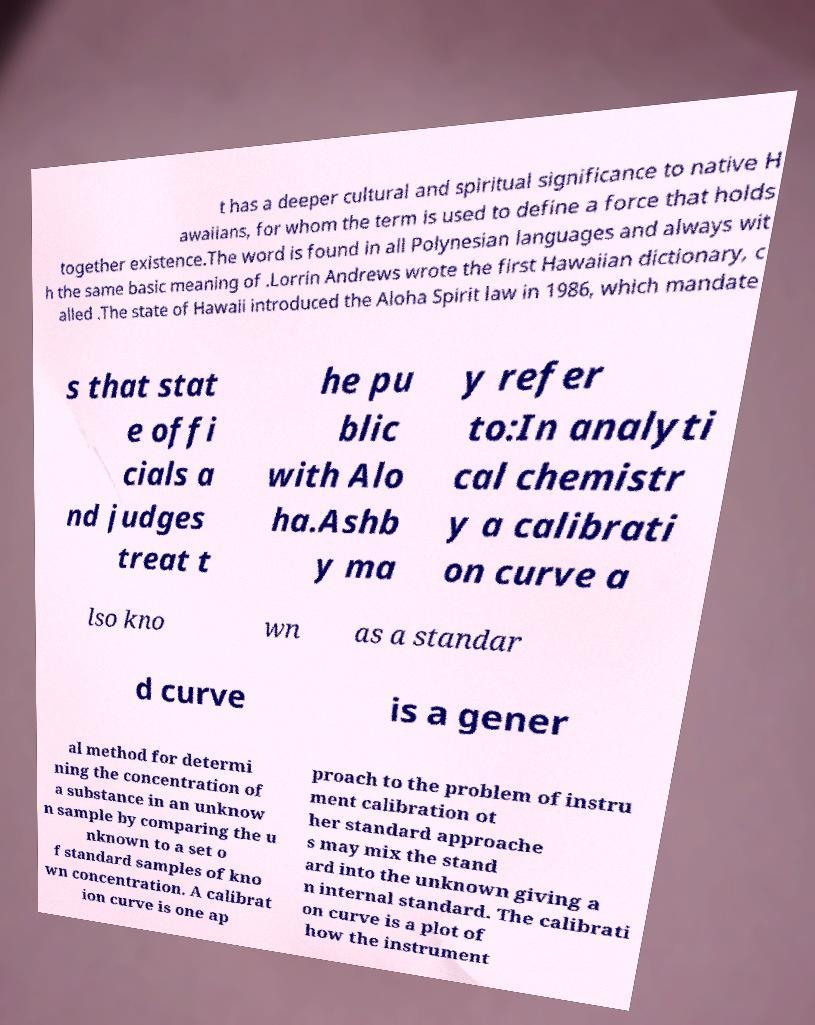Could you assist in decoding the text presented in this image and type it out clearly? t has a deeper cultural and spiritual significance to native H awaiians, for whom the term is used to define a force that holds together existence.The word is found in all Polynesian languages and always wit h the same basic meaning of .Lorrin Andrews wrote the first Hawaiian dictionary, c alled .The state of Hawaii introduced the Aloha Spirit law in 1986, which mandate s that stat e offi cials a nd judges treat t he pu blic with Alo ha.Ashb y ma y refer to:In analyti cal chemistr y a calibrati on curve a lso kno wn as a standar d curve is a gener al method for determi ning the concentration of a substance in an unknow n sample by comparing the u nknown to a set o f standard samples of kno wn concentration. A calibrat ion curve is one ap proach to the problem of instru ment calibration ot her standard approache s may mix the stand ard into the unknown giving a n internal standard. The calibrati on curve is a plot of how the instrument 